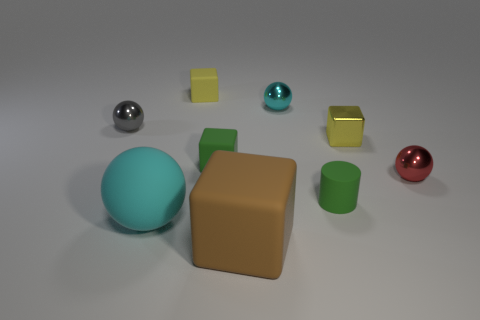The rubber object that is the same color as the cylinder is what shape?
Give a very brief answer. Cube. There is a gray metallic ball; is its size the same as the yellow cube that is to the right of the brown thing?
Keep it short and to the point. Yes. What material is the small red object that is the same shape as the small gray shiny object?
Offer a terse response. Metal. There is a green object that is left of the tiny green rubber thing right of the cube that is in front of the small red metal thing; what is its size?
Give a very brief answer. Small. Is the green cylinder the same size as the cyan metal sphere?
Your answer should be compact. Yes. The cyan sphere that is behind the cyan thing in front of the cyan shiny thing is made of what material?
Offer a terse response. Metal. There is a cyan thing that is behind the small cylinder; is it the same shape as the large matte thing that is right of the small yellow matte block?
Your answer should be very brief. No. Are there an equal number of red shiny spheres behind the small red sphere and tiny matte things?
Keep it short and to the point. No. Are there any tiny cyan objects that are in front of the small sphere that is on the left side of the large brown object?
Offer a terse response. No. Is there any other thing of the same color as the large cube?
Your answer should be very brief. No. 